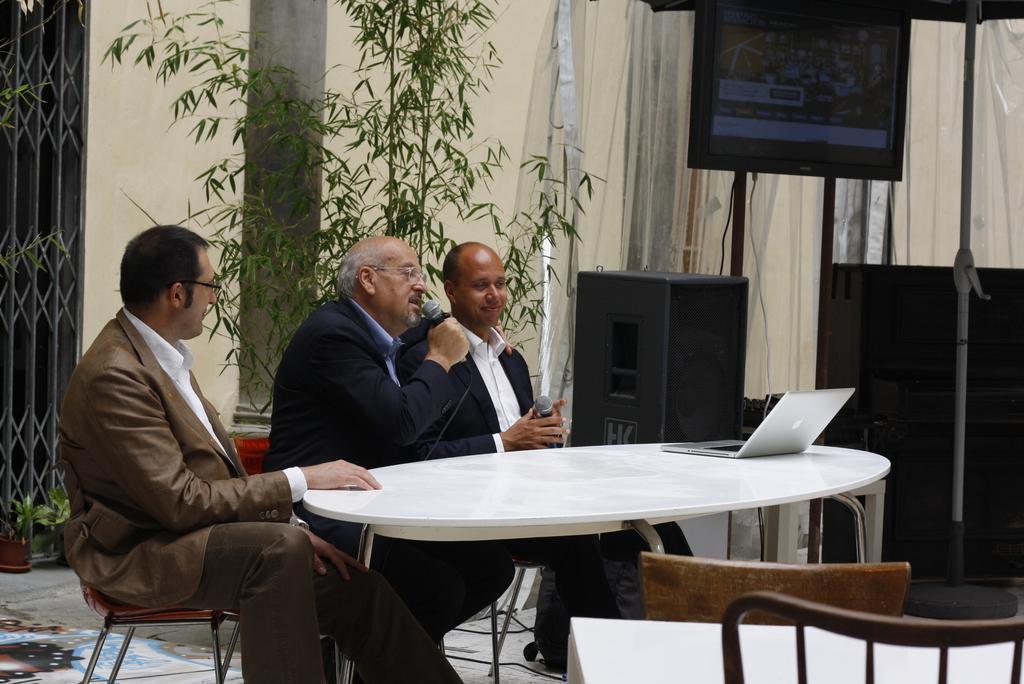Please provide a concise description of this image. In the image we can see there are three men who are sitting on chair and holding mic in their hand. 